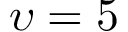<formula> <loc_0><loc_0><loc_500><loc_500>\upsilon = 5</formula> 